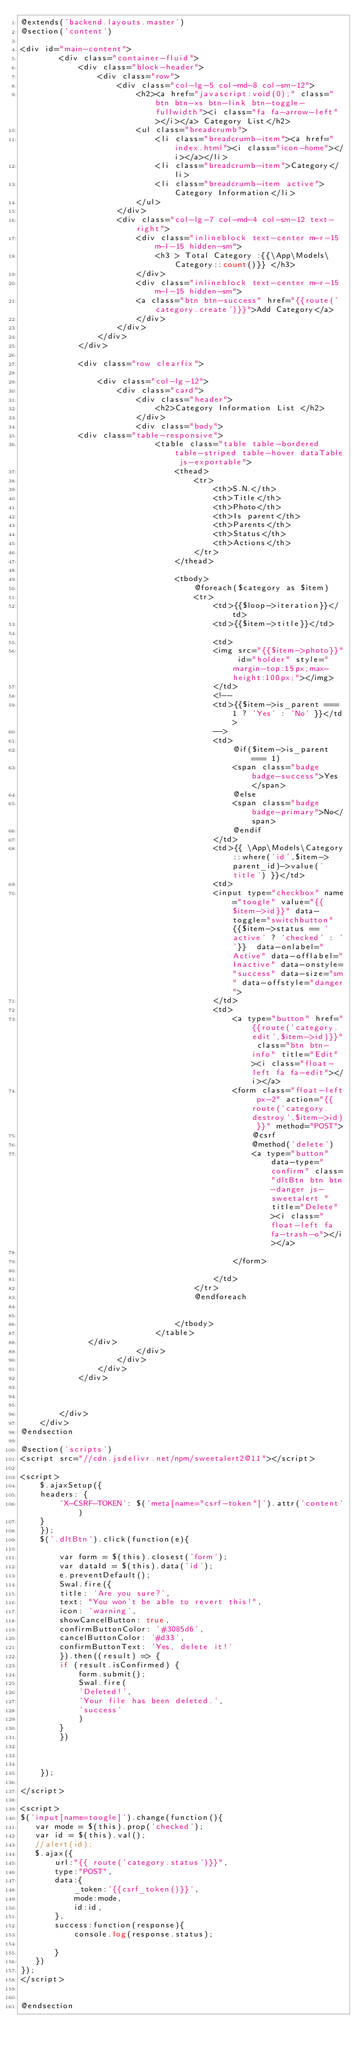Convert code to text. <code><loc_0><loc_0><loc_500><loc_500><_PHP_>@extends('backend.layouts.master')
@section('content')
 
<div id="main-content">
        <div class="container-fluid">
            <div class="block-header">
                <div class="row">
                    <div class="col-lg-5 col-md-8 col-sm-12">                        
                        <h2><a href="javascript:void(0);" class="btn btn-xs btn-link btn-toggle-fullwidth"><i class="fa fa-arrow-left"></i></a> Category List</h2>
                        <ul class="breadcrumb">
                            <li class="breadcrumb-item"><a href="index.html"><i class="icon-home"></i></a></li>                            
                            <li class="breadcrumb-item">Category</li>
                            <li class="breadcrumb-item active">Category Information</li>
                        </ul>
                    </div>            
                    <div class="col-lg-7 col-md-4 col-sm-12 text-right">
                        <div class="inlineblock text-center m-r-15 m-l-15 hidden-sm">
                            <h3 > Total Category :{{\App\Models\Category::count()}} </h3>
                        </div>
                        <div class="inlineblock text-center m-r-15 m-l-15 hidden-sm">
                        <a class="btn btn-success" href="{{route('category.create')}}">Add Category</a>
                        </div>
                    </div>
                </div>
            </div>
            
            <div class="row clearfix">
                
                <div class="col-lg-12">
                    <div class="card">
                        <div class="header">
                            <h2>Category Information List </h2>                            
                        </div>
                        <div class="body">
						<div class="table-responsive">
                            <table class="table table-bordered table-striped table-hover dataTable js-exportable">
                                <thead>
                                    <tr>
                                        <th>S.N.</th>
                                        <th>Title</th>
                                        <th>Photo</th>
                                        <th>Is parent</th>
                                        <th>Parents</th>
                                        <th>Status</th>
                                        <th>Actions</th>
                                    </tr>
                                </thead>
                               
                                <tbody>
                                    @foreach($category as $item)
                                    <tr>
                                        <td>{{$loop->iteration}}</td>
                                        <td>{{$item->title}}</td>
                                        
                                        <td>
                                        <img src="{{$item->photo}}" id="holder" style="margin-top:15px;max-height:100px;"></img>
                                        </td>
                                        <!--
                                        <td>{{$item->is_parent === 1 ? 'Yes' : 'No' }}</td>
                                        -->
                                        <td>
                                            @if($item->is_parent === 1)
                                            <span class="badge badge-success">Yes</span>
                                            @else
                                            <span class="badge badge-primary">No</span>
                                            @endif
                                        </td>
                                        <td>{{ \App\Models\Category::where('id',$item->	parent_id)->value('title') }}</td>
                                        <td>
                                        <input type="checkbox" name="toogle" value="{{$item->id}}" data-toggle="switchbutton" {{$item->status == 'active' ? 'checked' : ''}}  data-onlabel="Active" data-offlabel="Inactive" data-onstyle="success" data-size="sm" data-offstyle="danger">
                                        </td>
                                        <td>
                                            <a type="button" href="{{route('category.edit',$item->id)}}" class="btn btn-info" title="Edit"><i class="float-left fa fa-edit"></i></a>
                                            <form class="float-left px-2" action="{{ route('category.destroy',$item->id) }}" method="POST">
                                                @csrf 
                                                @method('delete')
                                                <a type="button" data-type="confirm" class="dltBtn btn btn-danger js-sweetalert " title="Delete"><i class="float-left fa fa-trash-o"></i></a>

                                            </form>
                                            
                                        </td>
                                    </tr>
                                    @endforeach
                                  
                                   
                                </tbody>
                            </table>
							</div>
                        </div>
                    </div>
                </div>
            </div>

           

        </div>
    </div>
@endsection

@section('scripts')
<script src="//cdn.jsdelivr.net/npm/sweetalert2@11"></script>

<script>
    $.ajaxSetup({
    headers: {
        'X-CSRF-TOKEN': $('meta[name="csrf-token"]').attr('content')
    }
    });
    $('.dltBtn').click(function(e){
       
        var form = $(this).closest('form');
        var dataId = $(this).data('id');
        e.preventDefault();
        Swal.fire({
        title: 'Are you sure?',
        text: "You won't be able to revert this!",
        icon: 'warning',
        showCancelButton: true,
        confirmButtonColor: '#3085d6',
        cancelButtonColor: '#d33',
        confirmButtonText: 'Yes, delete it!'
        }).then((result) => {
        if (result.isConfirmed) {
            form.submit();
            Swal.fire(
            'Deleted!',
            'Your file has been deleted.',
            'success'
            )
        }
        })
        
        

    });

</script>

<script>
$('input[name=toogle]').change(function(){
   var mode = $(this).prop('checked');
   var id = $(this).val();
   //alert(id);
   $.ajax({
       url:"{{ route('category.status')}}",
       type:"POST",
       data:{
           _token:'{{csrf_token()}}',
           mode:mode,
           id:id,
       },
       success:function(response){
           console.log(response.status);

       }
   })
});
</script>


@endsection</code> 